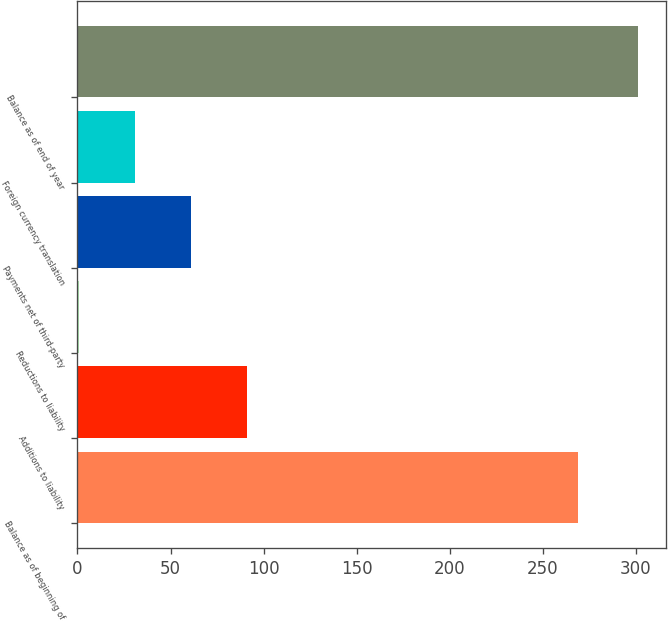<chart> <loc_0><loc_0><loc_500><loc_500><bar_chart><fcel>Balance as of beginning of<fcel>Additions to liability<fcel>Reductions to liability<fcel>Payments net of third-party<fcel>Foreign currency translation<fcel>Balance as of end of year<nl><fcel>269<fcel>91<fcel>1<fcel>61<fcel>31<fcel>301<nl></chart> 